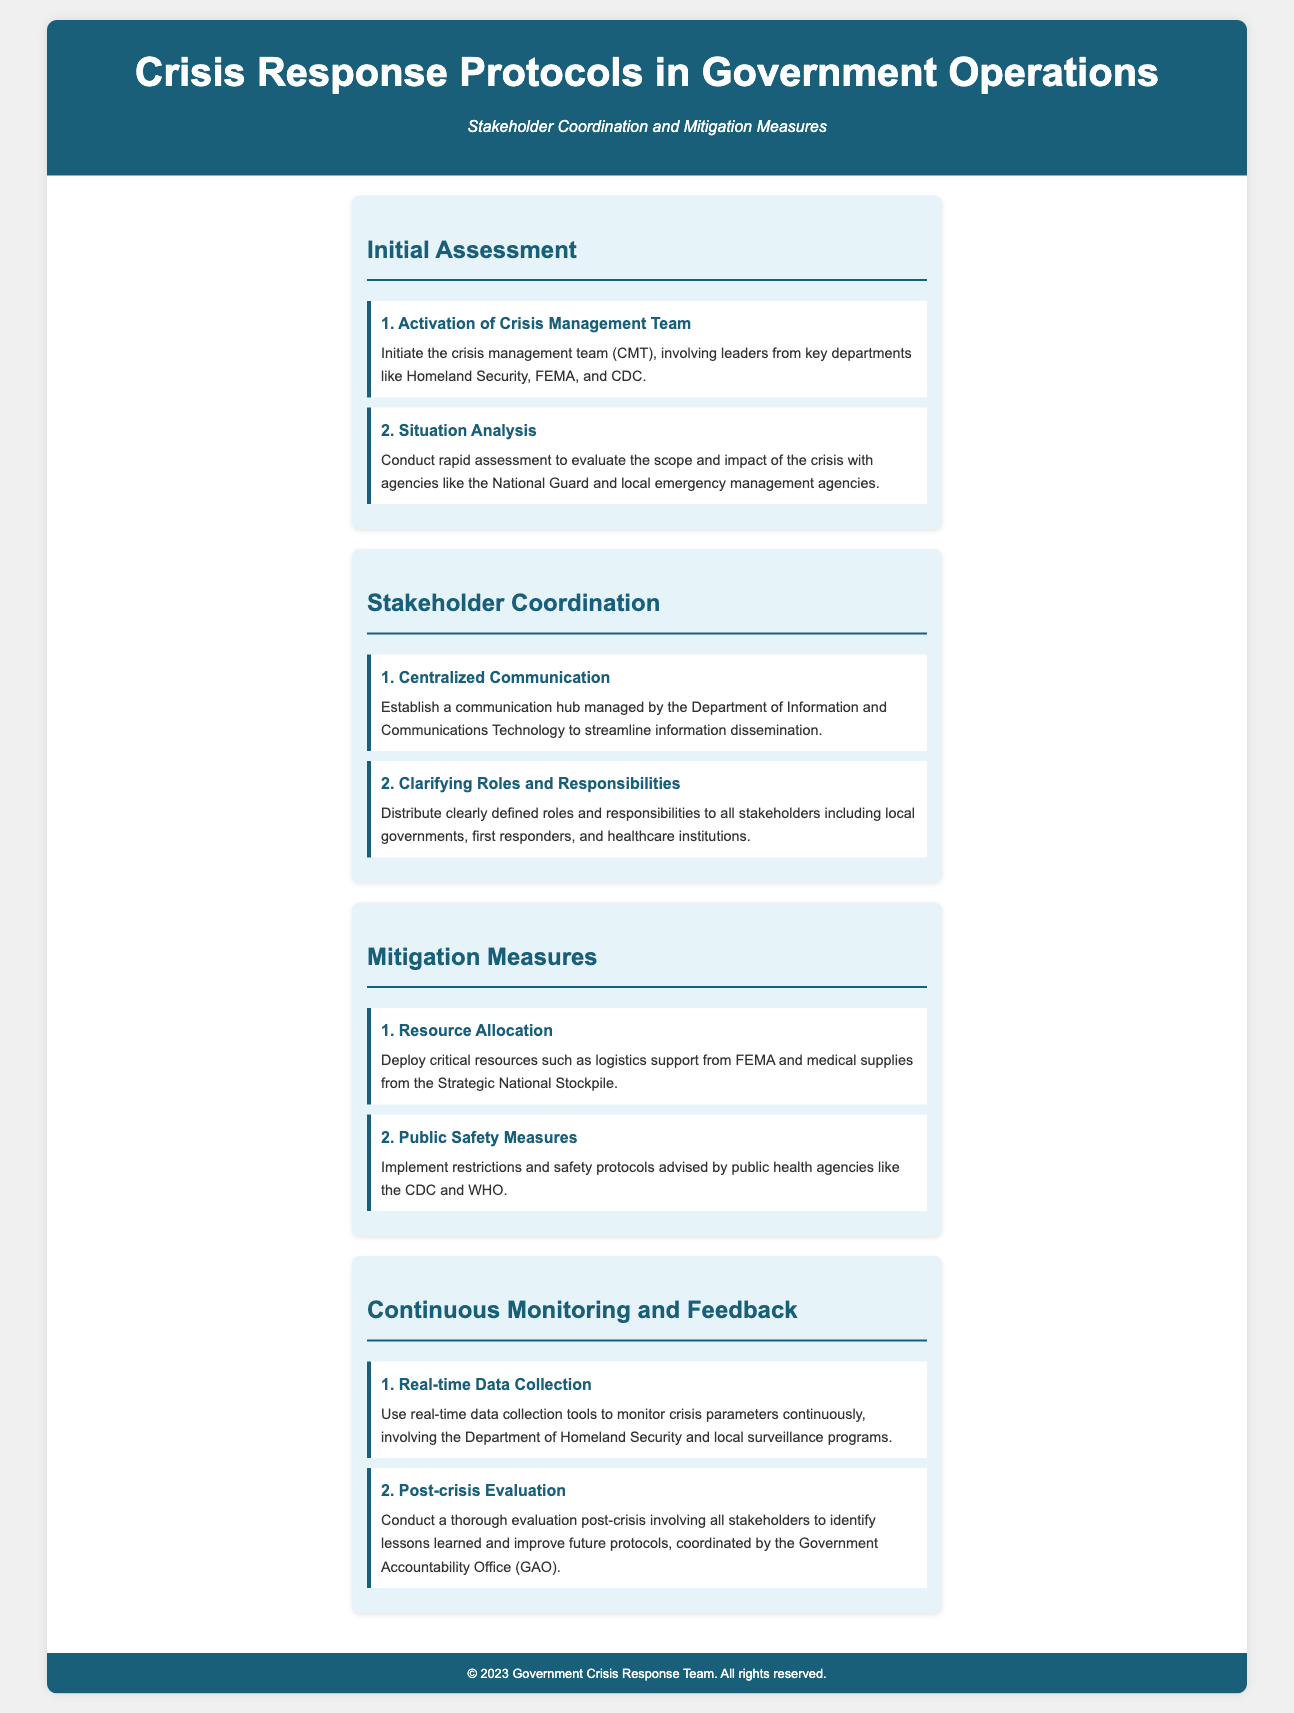What is the title of the document? The title of the document is presented prominently at the top of the infographic.
Answer: Crisis Response Protocols in Government Operations What are the two main focus areas of the document? The focus areas are noted in the subtitle, indicating the specific elements of crisis response covered in the infographic.
Answer: Stakeholder Coordination and Mitigation Measures Who activates the Crisis Management Team? The description under the step outlines who is involved in the activation of the team for initial assessment.
Answer: Leaders from key departments What is the first step in Stakeholder Coordination? The first step is described in the section dedicated to stakeholder actions during a crisis.
Answer: Centralized Communication Which department manages the communication hub? The document specifies the department responsible for establishing the communication hub.
Answer: Department of Information and Communications Technology What type of resources are allocated as a mitigation measure? This detail is revealed in the corresponding section discussing resource deployment during a crisis.
Answer: Critical resources What is implemented to ensure public safety? The document indicates measures implemented regarding public safety protocols during a crisis.
Answer: Restrictions and safety protocols What is used for real-time data collection? The section regarding continuous monitoring specifies what tools are employed for this purpose.
Answer: Real-time data collection tools What is conducted post-crisis according to the document? The document specifies the nature of the evaluation performed after a crisis.
Answer: A thorough evaluation Who coordinates the post-crisis evaluation? The infographic mentions which office is responsible for overseeing the evaluation process post-crisis.
Answer: Government Accountability Office (GAO) 